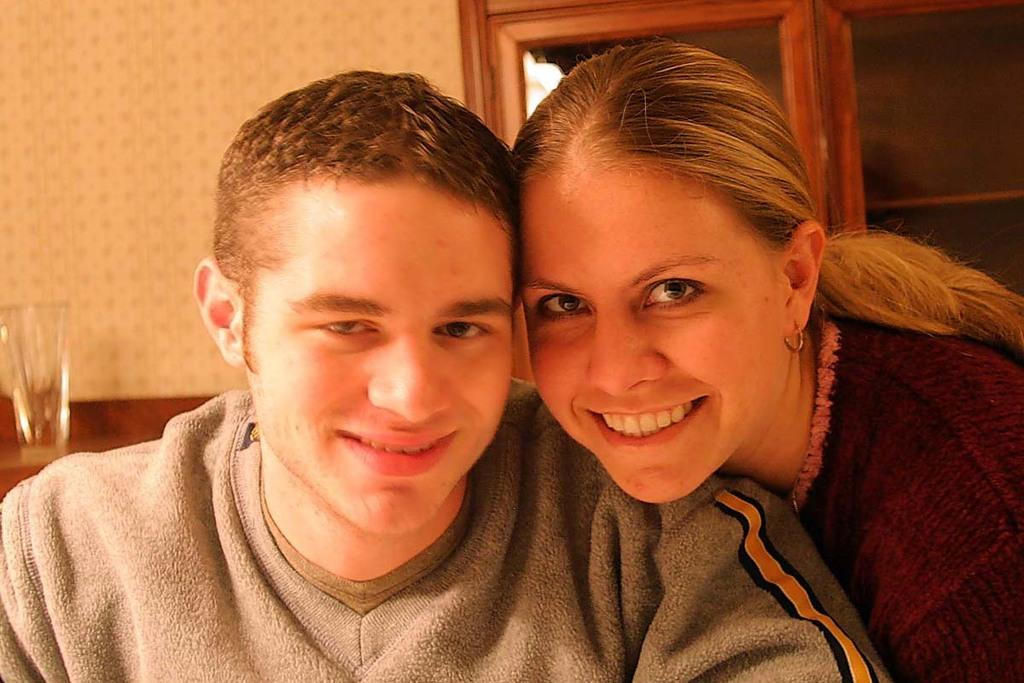Who is present in the image? There is a man and a woman in the image. What are the man and woman doing in the image? Both the man and woman are smiling and looking at a picture. What can be seen in the background of the image? There is a wall and a door in the background of the image. What is on the left side of the image? There is a glass on a table on the left side of the image. What type of ear can be seen in the image? There is no ear present in the image. What color is the ink used to write on the picture they are looking at? There is no writing or ink visible in the image, as it only shows the man and woman looking at a picture. 